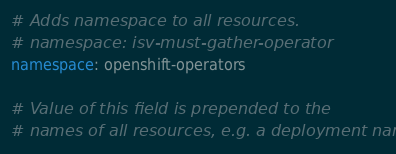Convert code to text. <code><loc_0><loc_0><loc_500><loc_500><_YAML_># Adds namespace to all resources.
# namespace: isv-must-gather-operator
namespace: openshift-operators

# Value of this field is prepended to the
# names of all resources, e.g. a deployment named</code> 